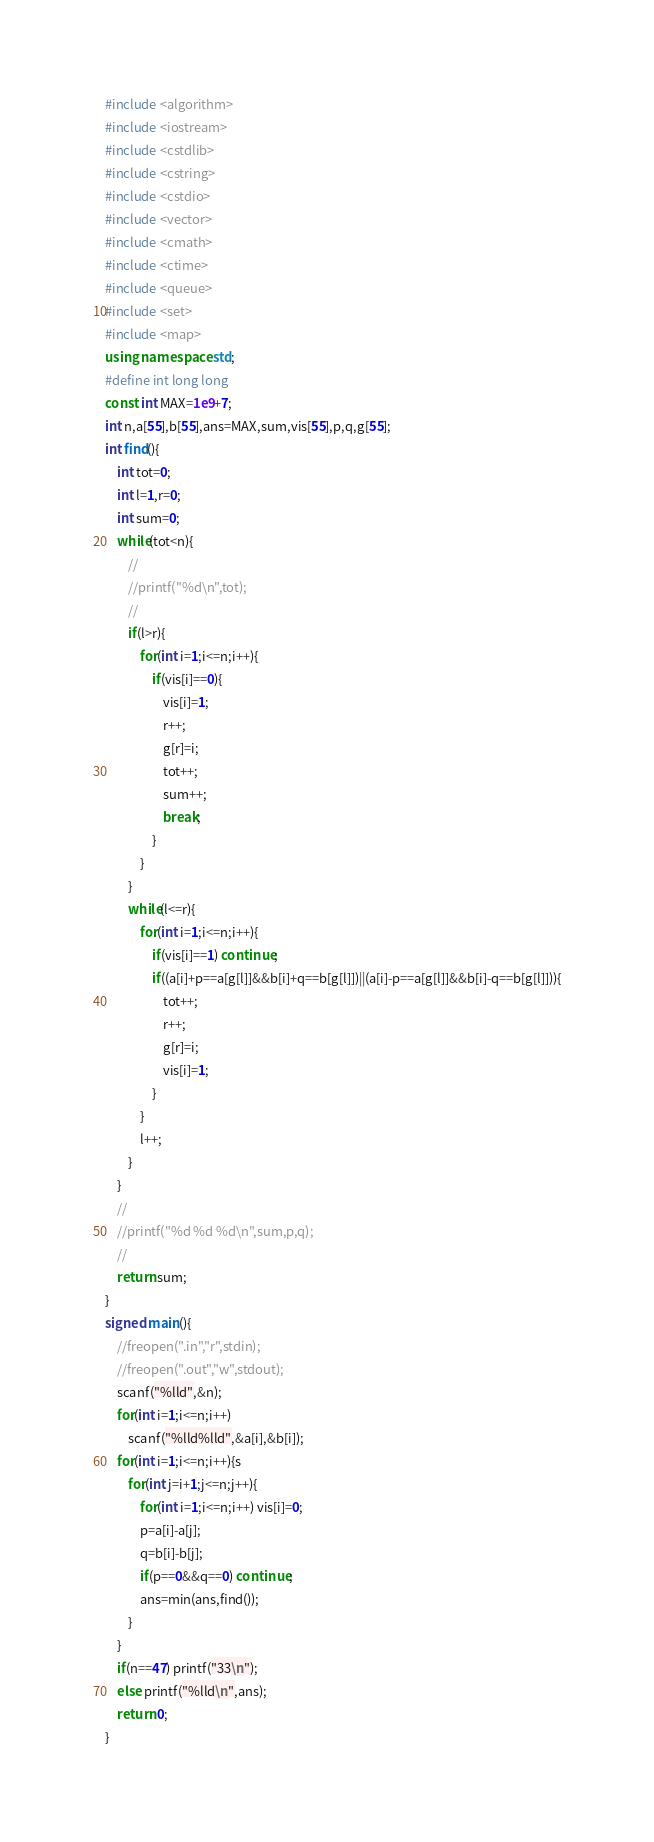Convert code to text. <code><loc_0><loc_0><loc_500><loc_500><_C++_>#include <algorithm>
#include <iostream>
#include <cstdlib>
#include <cstring>
#include <cstdio>
#include <vector>
#include <cmath>
#include <ctime>
#include <queue>
#include <set>
#include <map>
using namespace std;
#define int long long
const int MAX=1e9+7;
int n,a[55],b[55],ans=MAX,sum,vis[55],p,q,g[55];
int find(){
	int tot=0;
	int l=1,r=0;
	int sum=0;
	while(tot<n){
		//
		//printf("%d\n",tot);
		//
		if(l>r){
			for(int i=1;i<=n;i++){
				if(vis[i]==0){
					vis[i]=1;
					r++;
					g[r]=i;
					tot++;
					sum++;
					break;
				}
			}
		}
		while(l<=r){
			for(int i=1;i<=n;i++){
				if(vis[i]==1) continue;
				if((a[i]+p==a[g[l]]&&b[i]+q==b[g[l]])||(a[i]-p==a[g[l]]&&b[i]-q==b[g[l]])){
					tot++;
					r++;
					g[r]=i;
					vis[i]=1;
				}
			}
			l++;
		}
	}
	//
	//printf("%d %d %d\n",sum,p,q);
	//
	return sum;
}
signed main(){
	//freopen(".in","r",stdin);
	//freopen(".out","w",stdout);
	scanf("%lld",&n);
	for(int i=1;i<=n;i++)
		scanf("%lld%lld",&a[i],&b[i]);
	for(int i=1;i<=n;i++){s
		for(int j=i+1;j<=n;j++){
			for(int i=1;i<=n;i++) vis[i]=0;
			p=a[i]-a[j];
			q=b[i]-b[j];
			if(p==0&&q==0) continue;
			ans=min(ans,find());
		}
	}
	if(n==47) printf("33\n");
	else printf("%lld\n",ans);
	return 0;
}</code> 